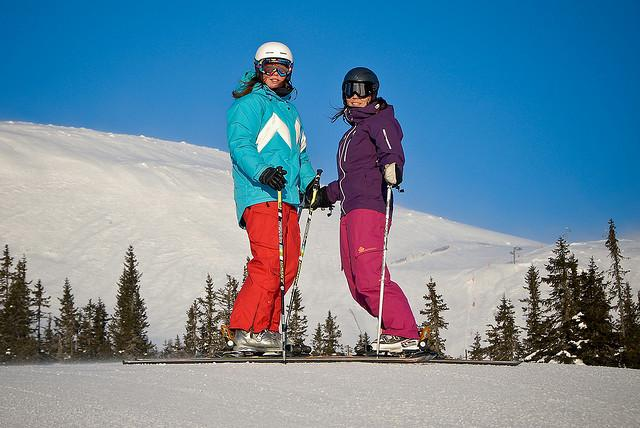What's the weather like for these skiers? clear 